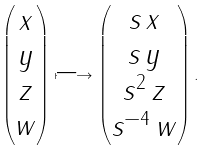<formula> <loc_0><loc_0><loc_500><loc_500>\begin{pmatrix} x \\ y \\ z \\ w \end{pmatrix} \longmapsto \begin{pmatrix} s \, x \\ s \, y \\ s ^ { 2 } \, z \\ s ^ { - 4 } \, w \end{pmatrix} .</formula> 